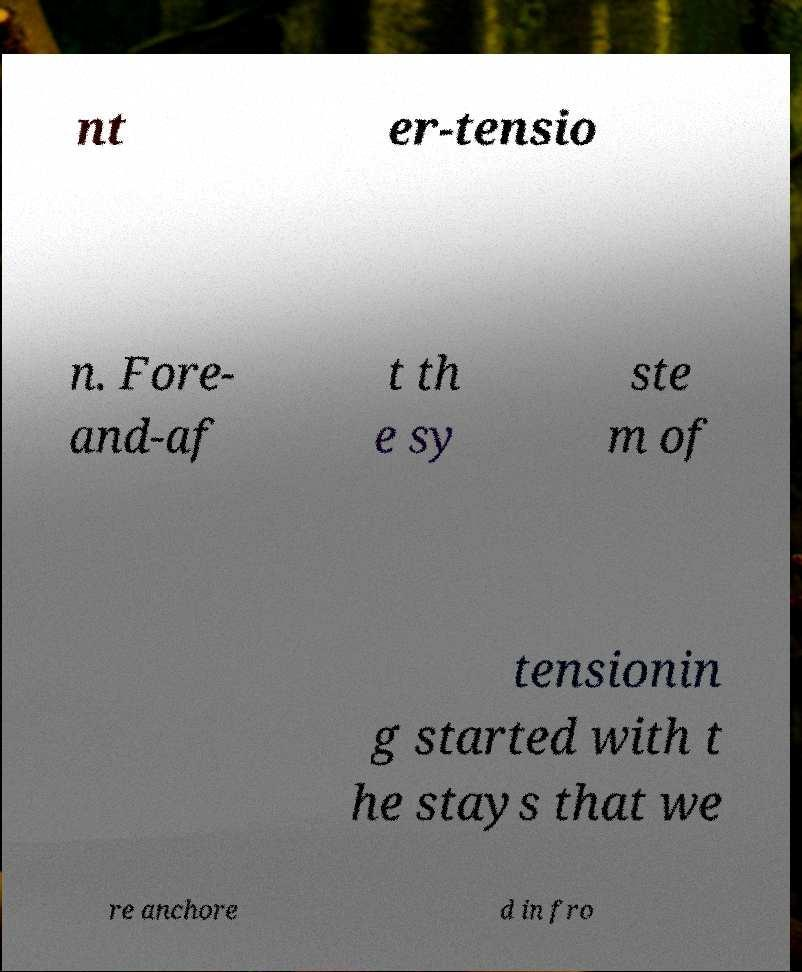Please identify and transcribe the text found in this image. nt er-tensio n. Fore- and-af t th e sy ste m of tensionin g started with t he stays that we re anchore d in fro 